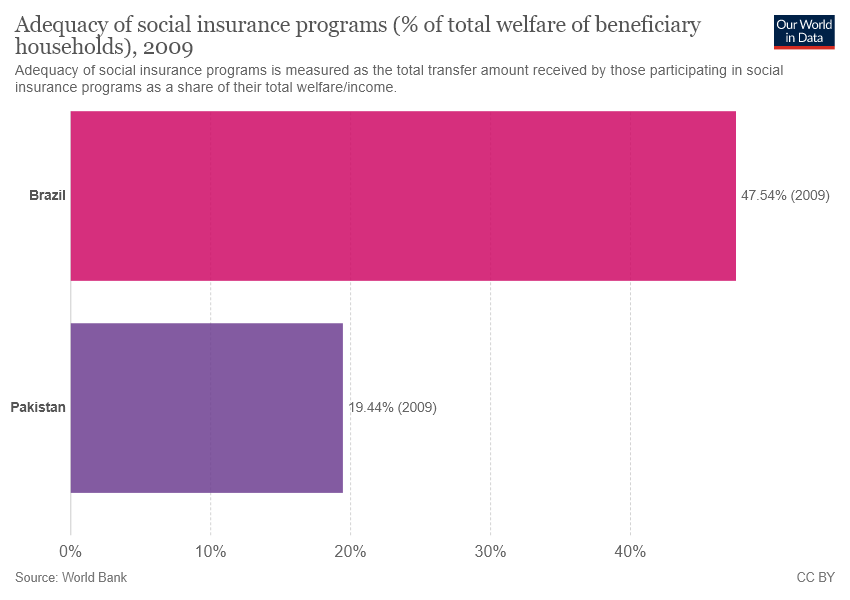Point out several critical features in this image. The adequacy of social insurance programs in Brazil and Pakistan are separately 66.98% and 28.1%, respectively. This graph presents data from two countries: Brazil and Pakistan. 